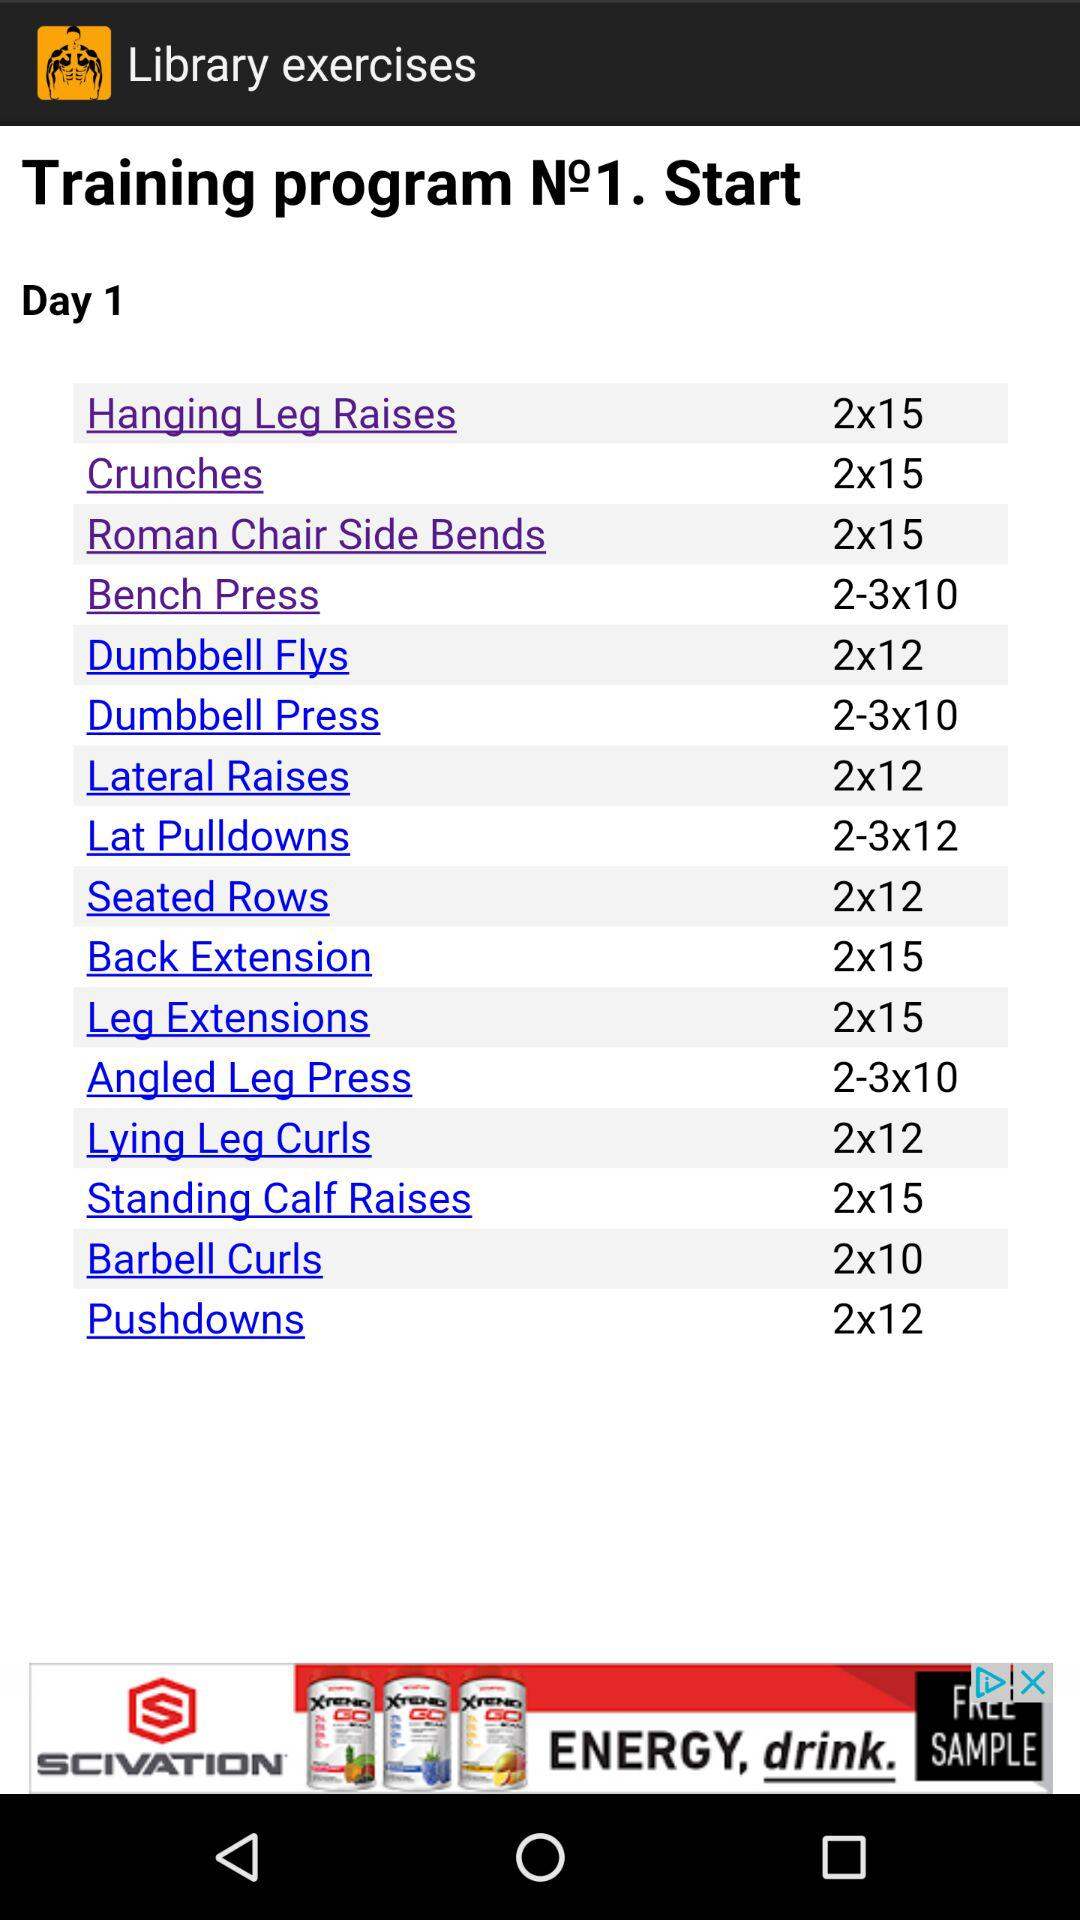What is the number of repetitions for pushdowns? The number of repetitions for pushdowns is 12. 